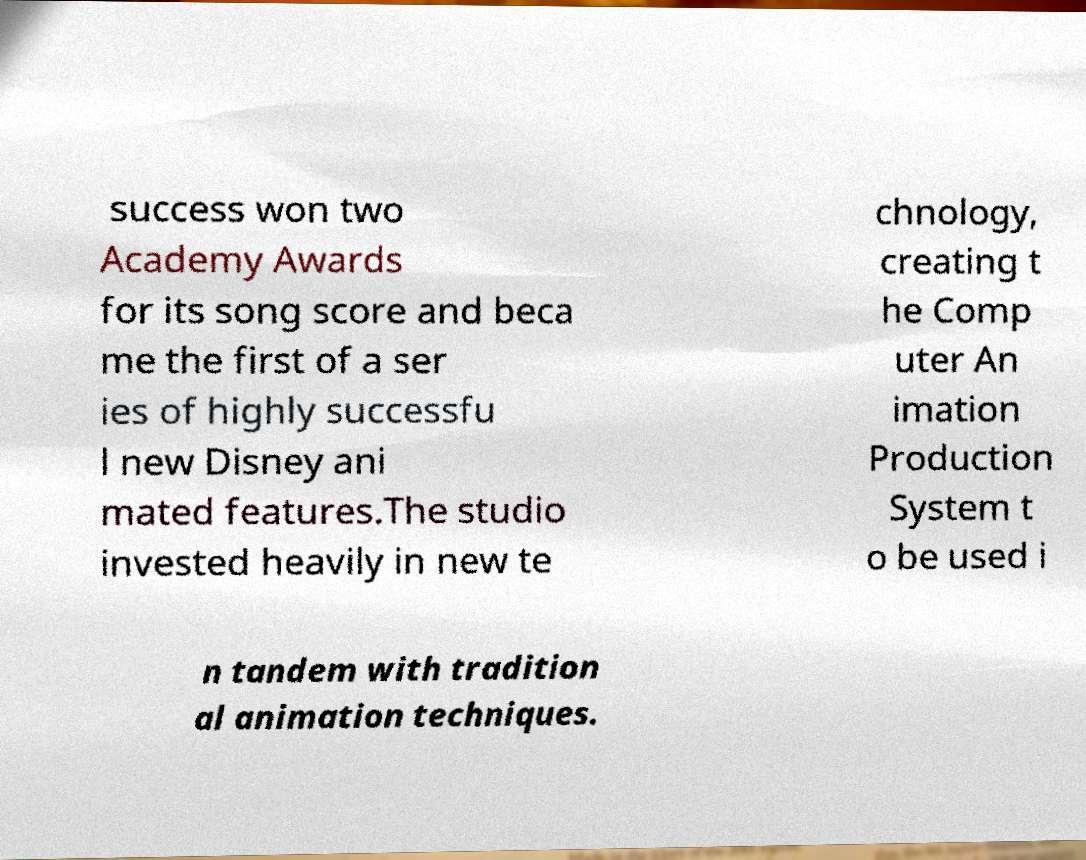Could you assist in decoding the text presented in this image and type it out clearly? success won two Academy Awards for its song score and beca me the first of a ser ies of highly successfu l new Disney ani mated features.The studio invested heavily in new te chnology, creating t he Comp uter An imation Production System t o be used i n tandem with tradition al animation techniques. 